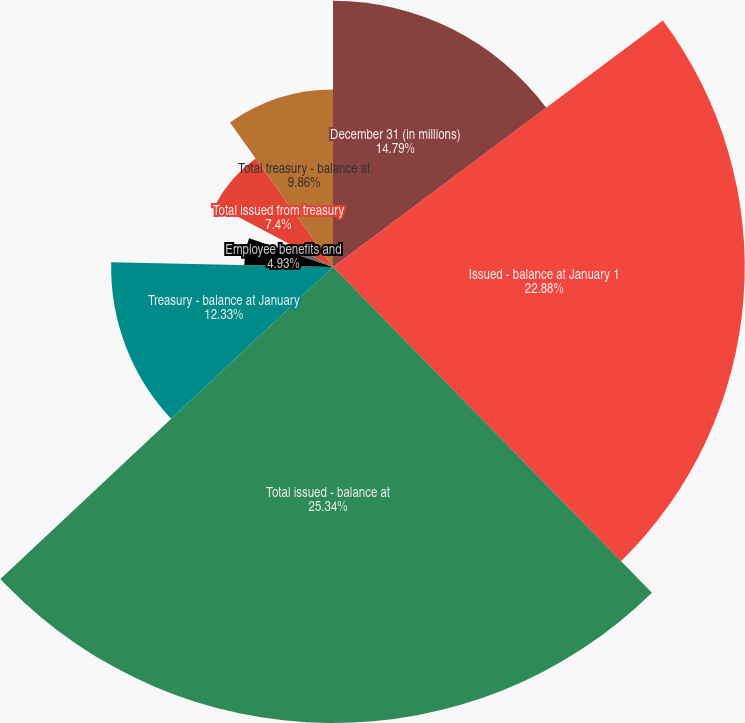<chart> <loc_0><loc_0><loc_500><loc_500><pie_chart><fcel>December 31 (in millions)<fcel>Issued - balance at January 1<fcel>Total issued - balance at<fcel>Treasury - balance at January<fcel>Share repurchases related to<fcel>Employee benefits and<fcel>Employee stock purchase plans<fcel>Total issued from treasury<fcel>Total treasury - balance at<nl><fcel>14.79%<fcel>22.88%<fcel>25.34%<fcel>12.33%<fcel>0.0%<fcel>4.93%<fcel>2.47%<fcel>7.4%<fcel>9.86%<nl></chart> 